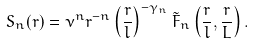<formula> <loc_0><loc_0><loc_500><loc_500>S _ { n } ( r ) = \nu ^ { n } r ^ { - n } \left ( \frac { r } { l } \right ) ^ { - \gamma _ { n } } \tilde { F } _ { n } \left ( \frac { r } { l } , \frac { r } { L } \right ) .</formula> 